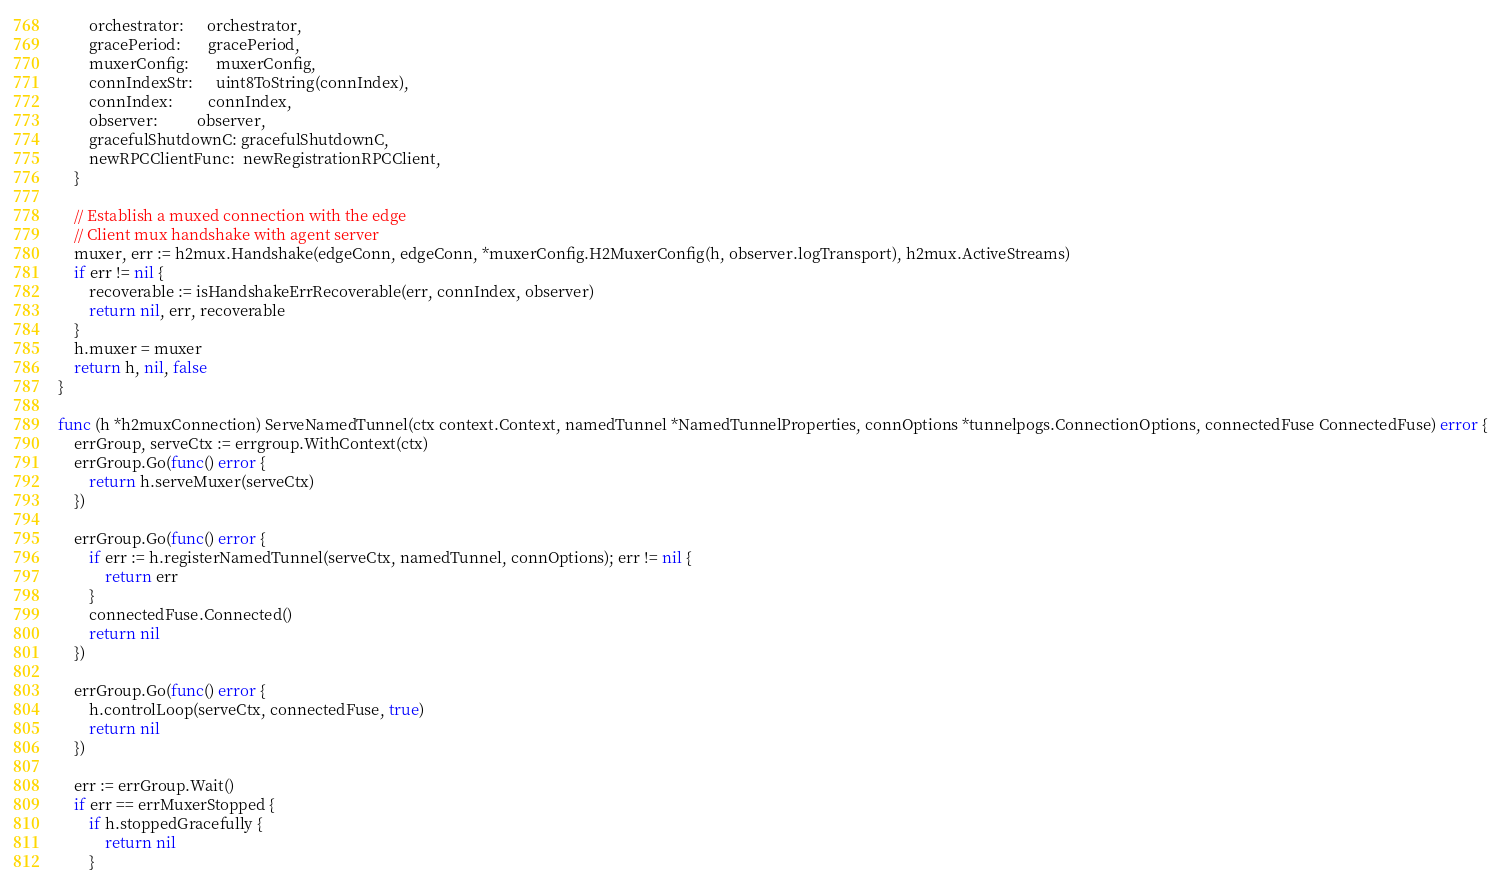Convert code to text. <code><loc_0><loc_0><loc_500><loc_500><_Go_>		orchestrator:      orchestrator,
		gracePeriod:       gracePeriod,
		muxerConfig:       muxerConfig,
		connIndexStr:      uint8ToString(connIndex),
		connIndex:         connIndex,
		observer:          observer,
		gracefulShutdownC: gracefulShutdownC,
		newRPCClientFunc:  newRegistrationRPCClient,
	}

	// Establish a muxed connection with the edge
	// Client mux handshake with agent server
	muxer, err := h2mux.Handshake(edgeConn, edgeConn, *muxerConfig.H2MuxerConfig(h, observer.logTransport), h2mux.ActiveStreams)
	if err != nil {
		recoverable := isHandshakeErrRecoverable(err, connIndex, observer)
		return nil, err, recoverable
	}
	h.muxer = muxer
	return h, nil, false
}

func (h *h2muxConnection) ServeNamedTunnel(ctx context.Context, namedTunnel *NamedTunnelProperties, connOptions *tunnelpogs.ConnectionOptions, connectedFuse ConnectedFuse) error {
	errGroup, serveCtx := errgroup.WithContext(ctx)
	errGroup.Go(func() error {
		return h.serveMuxer(serveCtx)
	})

	errGroup.Go(func() error {
		if err := h.registerNamedTunnel(serveCtx, namedTunnel, connOptions); err != nil {
			return err
		}
		connectedFuse.Connected()
		return nil
	})

	errGroup.Go(func() error {
		h.controlLoop(serveCtx, connectedFuse, true)
		return nil
	})

	err := errGroup.Wait()
	if err == errMuxerStopped {
		if h.stoppedGracefully {
			return nil
		}</code> 